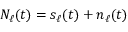<formula> <loc_0><loc_0><loc_500><loc_500>N _ { \ell } ( t ) = s _ { \ell } ( t ) + n _ { \ell } ( t )</formula> 